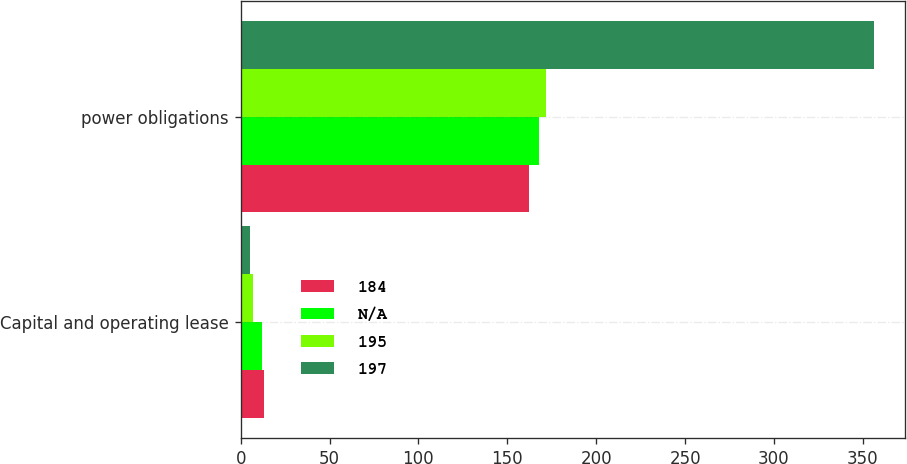Convert chart to OTSL. <chart><loc_0><loc_0><loc_500><loc_500><stacked_bar_chart><ecel><fcel>Capital and operating lease<fcel>power obligations<nl><fcel>184<fcel>13<fcel>162<nl><fcel>nan<fcel>12<fcel>168<nl><fcel>195<fcel>7<fcel>172<nl><fcel>197<fcel>5<fcel>356<nl></chart> 